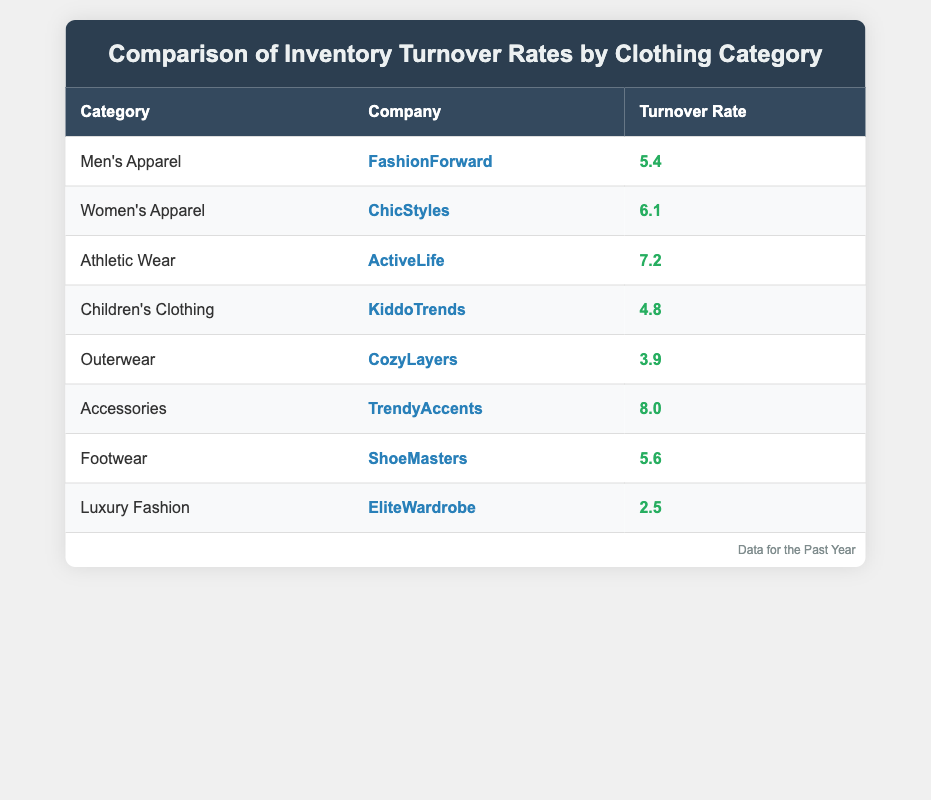What is the turnover rate for Accessories? The table lists the turnover rates for various categories, and for Accessories, the turnover rate is given directly as 8.0.
Answer: 8.0 Which clothing category has the highest inventory turnover rate? By inspecting the table, Athletic Wear has the highest turnover rate listed at 7.2, higher than all other categories.
Answer: Athletic Wear What is the turnover rate difference between Women’s Apparel and Children’s Clothing? The turnover rate for Women's Apparel is 6.1 and for Children's Clothing is 4.8. The difference can be calculated as 6.1 - 4.8 = 1.3.
Answer: 1.3 Is the turnover rate for Luxury Fashion higher than that for Outerwear? The turnover rate for Luxury Fashion is 2.5, while for Outerwear it is 3.9. Since 2.5 is less than 3.9, we conclude that the statement is false.
Answer: No What is the average turnover rate for Men’s Apparel and Footwear? The turnover rates for Men's Apparel is 5.4 and for Footwear is 5.6. Adding these values gives 5.4 + 5.6 = 11.0. Now, divide by 2 for the average: 11.0 / 2 = 5.5.
Answer: 5.5 How many categories have a turnover rate below 5.0? By reviewing the table, we find that Children’s Clothing (4.8) and Outerwear (3.9) are the only two categories with rates below 5.0. Thus, there are 2 categories.
Answer: 2 Which company has the lowest inventory turnover rate, and what is it? The table shows that EliteWardrobe has the lowest turnover rate of 2.5, which is lower than all other listed companies.
Answer: EliteWardrobe, 2.5 What is the total turnover rate for Accessories and Athletic Wear combined? The turnover rate for Accessories is 8.0 and for Athletic Wear it is 7.2. Adding these gives a total of 8.0 + 7.2 = 15.2.
Answer: 15.2 Are there more companies with a turnover rate above 6.0 than below? Inspecting the table reveals that there are three companies with turnover rates above 6.0 (Women's Apparel, Athletic Wear, and Accessories) and five below (Men's Apparel, Children's Clothing, Outerwear, Footwear, and Luxury Fashion). Since 3 is less than 5, the answer is false.
Answer: No 